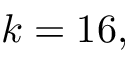Convert formula to latex. <formula><loc_0><loc_0><loc_500><loc_500>k = 1 6 ,</formula> 